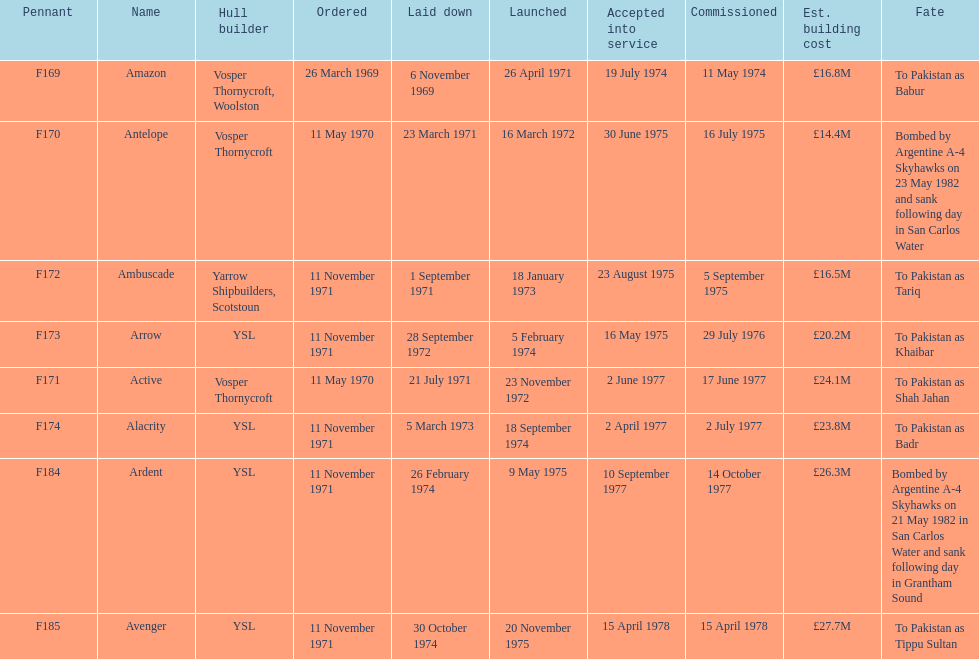The arrow was ordered on november 11, 1971. what was the previous ship? Ambuscade. 